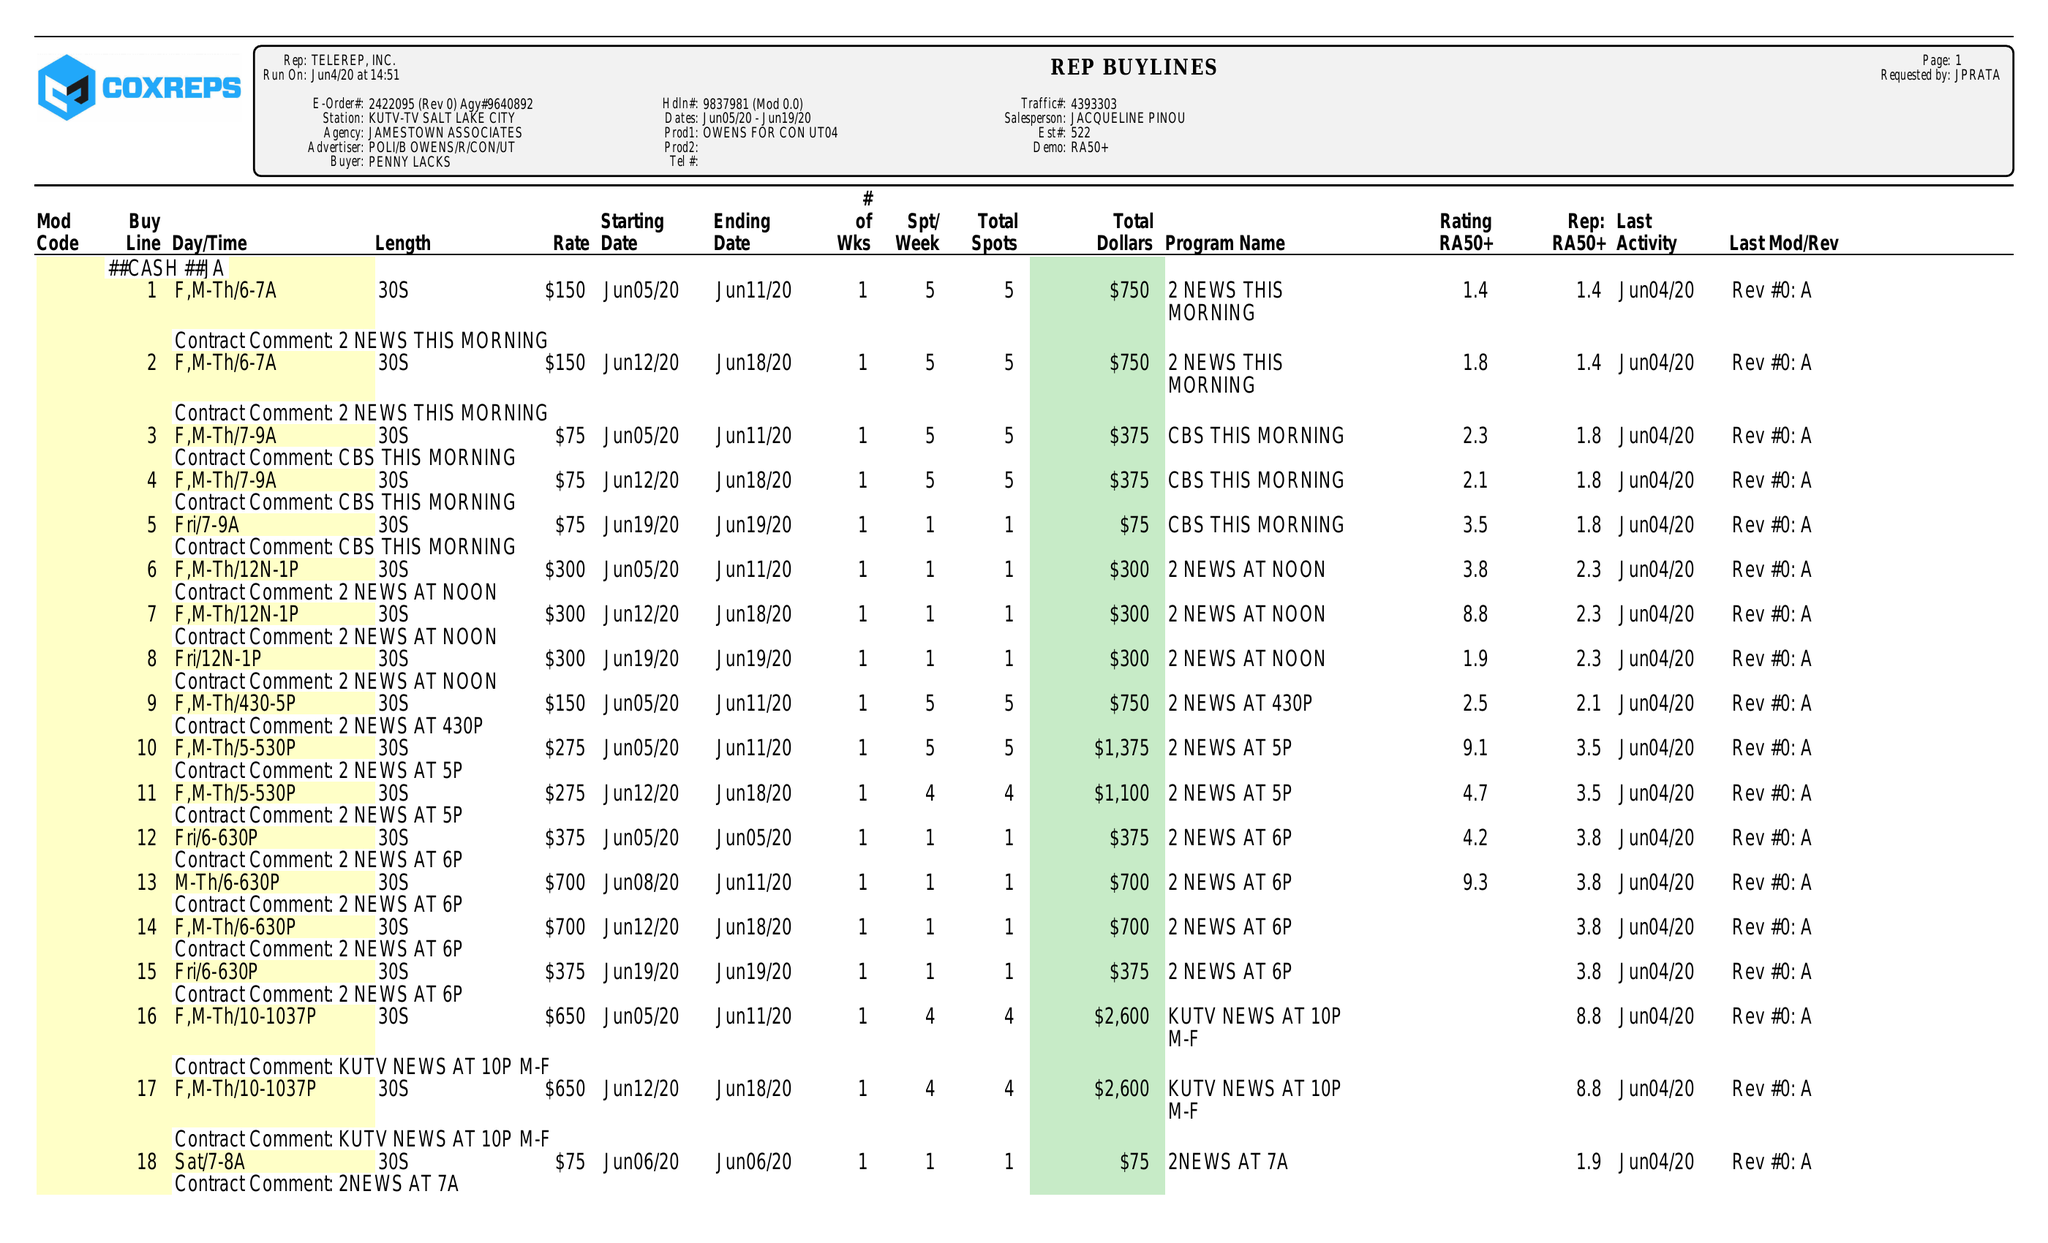What is the value for the flight_to?
Answer the question using a single word or phrase. 06/19/20 